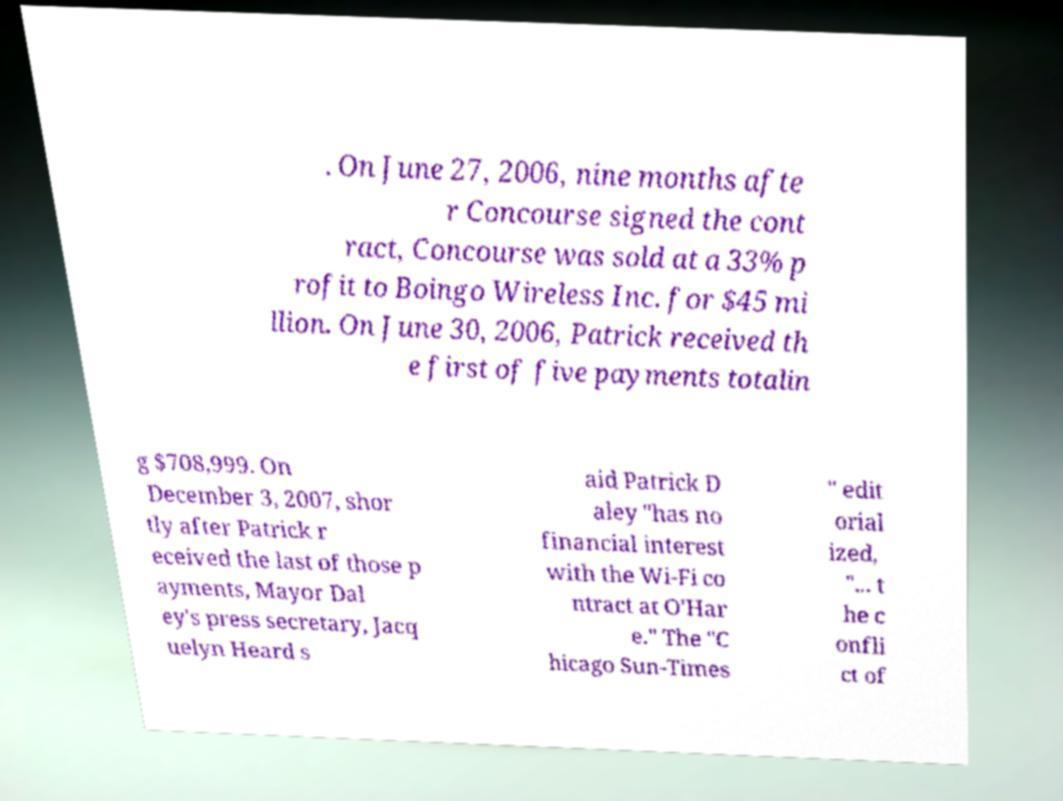There's text embedded in this image that I need extracted. Can you transcribe it verbatim? . On June 27, 2006, nine months afte r Concourse signed the cont ract, Concourse was sold at a 33% p rofit to Boingo Wireless Inc. for $45 mi llion. On June 30, 2006, Patrick received th e first of five payments totalin g $708,999. On December 3, 2007, shor tly after Patrick r eceived the last of those p ayments, Mayor Dal ey's press secretary, Jacq uelyn Heard s aid Patrick D aley "has no financial interest with the Wi-Fi co ntract at O'Har e." The "C hicago Sun-Times " edit orial ized, "... t he c onfli ct of 